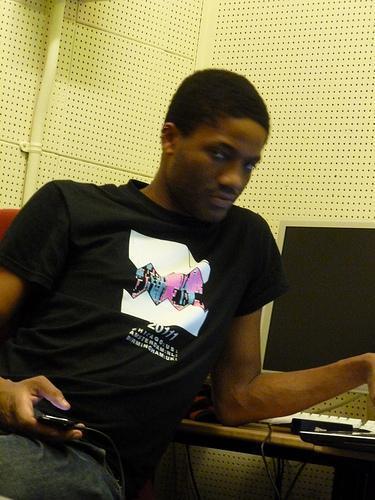How many people in the photo?
Give a very brief answer. 1. 